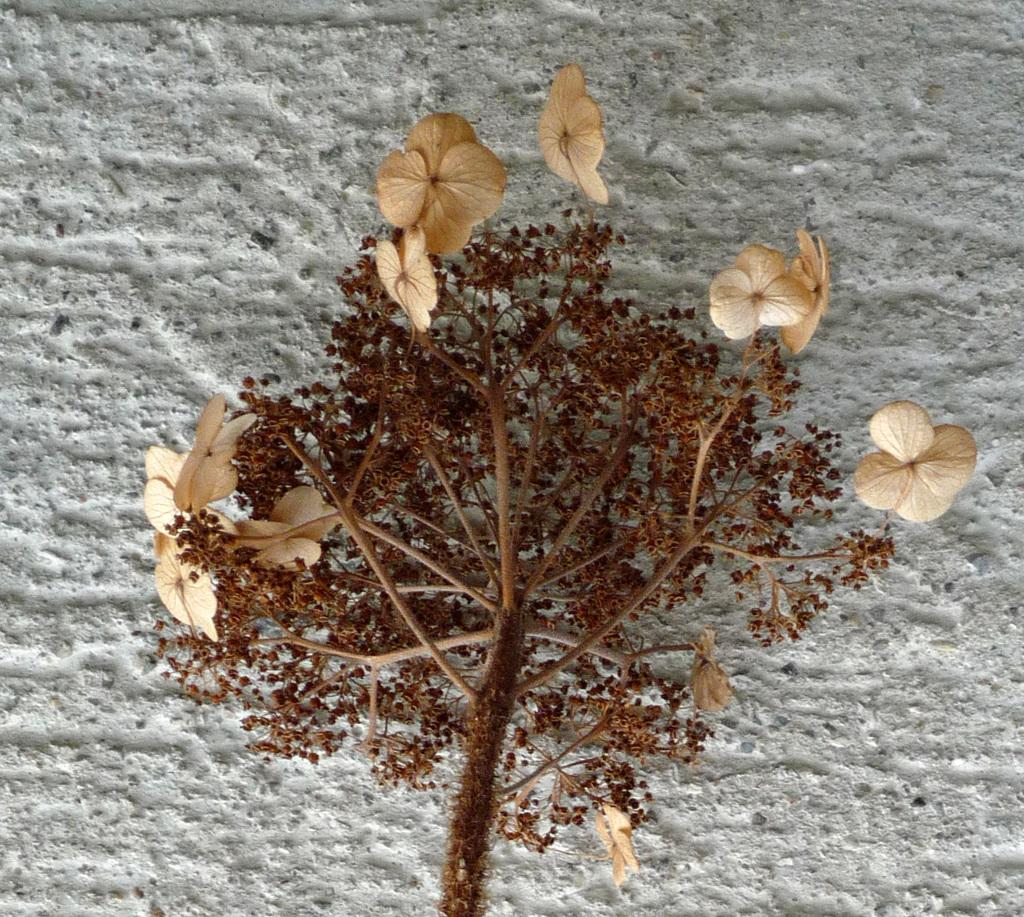What type of living organism is present in the image? There is a plant in the image. What are the reproductive parts of the plant visible in the image? The plant has flowers and buds. What is located behind the plant in the image? There is a wall behind the plant. What type of flesh can be seen on the plant in the image? There is no flesh present on the plant in the image; it is a plant with flowers and buds. What historical event is depicted in the image? There is no historical event depicted in the image; it features a plant with flowers and buds in front of a wall. 